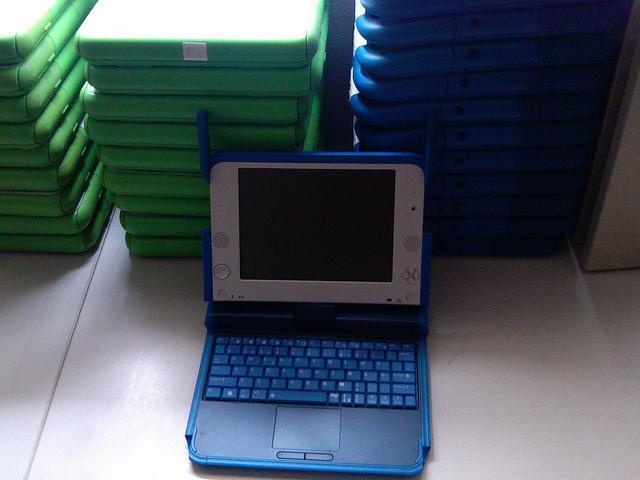How many people have ties on?
Give a very brief answer. 0. 